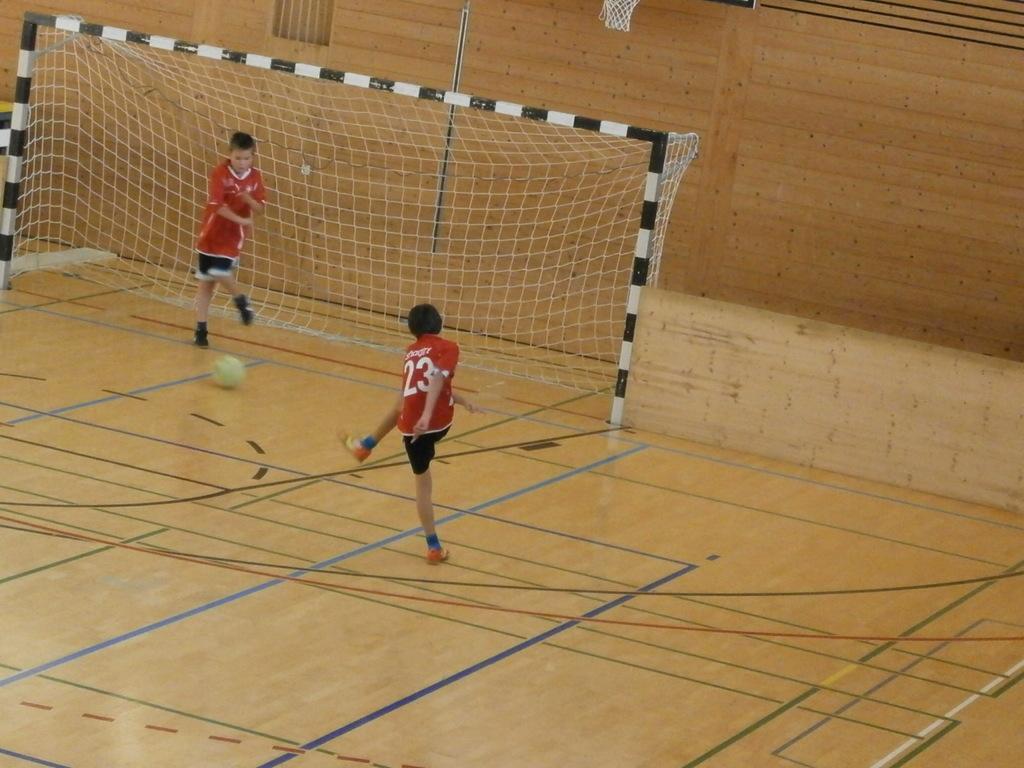Could you give a brief overview of what you see in this image? In this image, we can see two people are playing football on the floor. Here we can see ball, net with rods. Background there is a wall. 